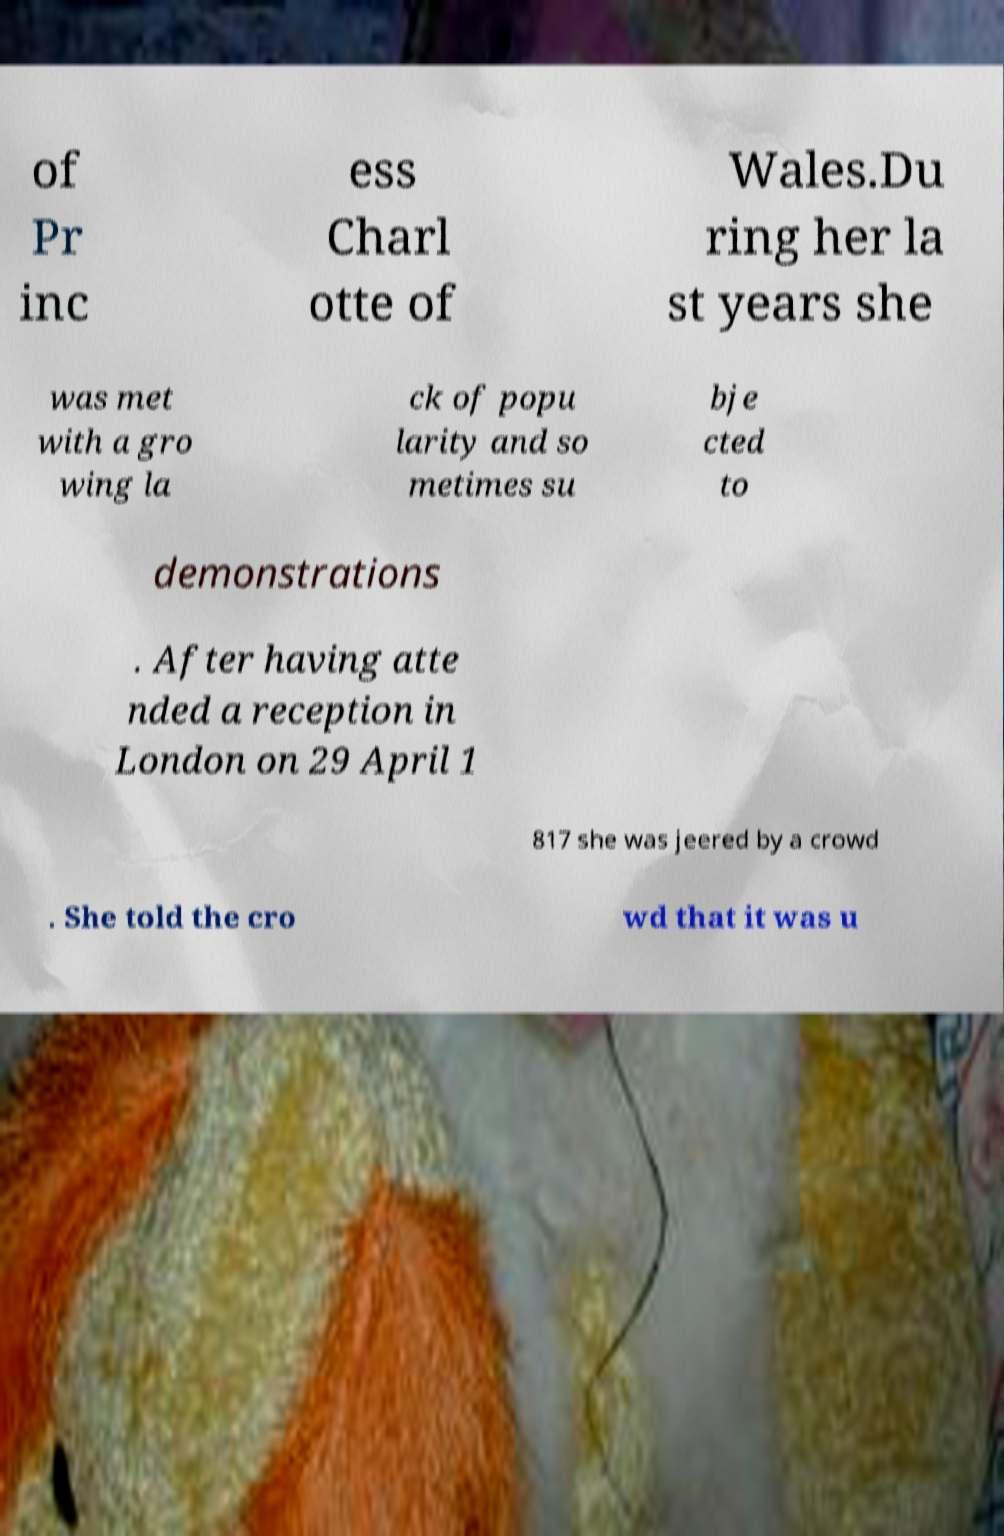For documentation purposes, I need the text within this image transcribed. Could you provide that? of Pr inc ess Charl otte of Wales.Du ring her la st years she was met with a gro wing la ck of popu larity and so metimes su bje cted to demonstrations . After having atte nded a reception in London on 29 April 1 817 she was jeered by a crowd . She told the cro wd that it was u 